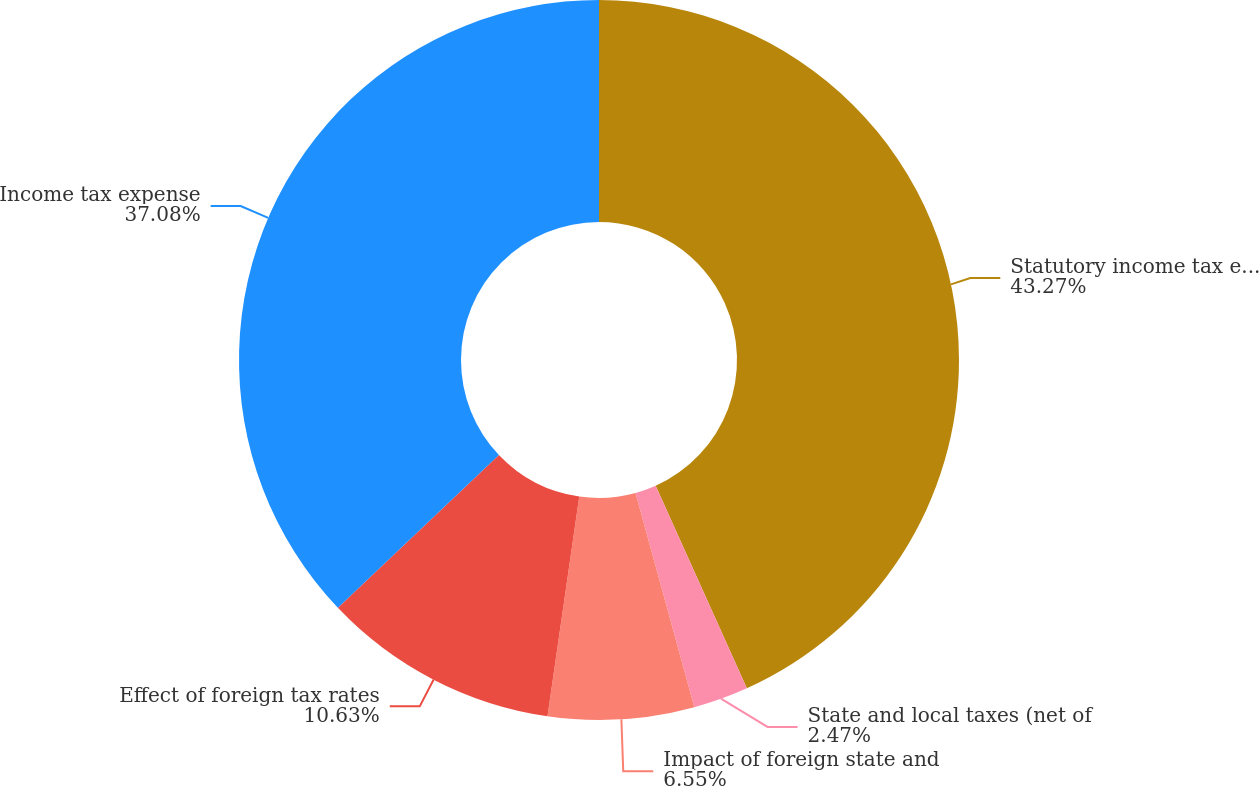Convert chart. <chart><loc_0><loc_0><loc_500><loc_500><pie_chart><fcel>Statutory income tax expense<fcel>State and local taxes (net of<fcel>Impact of foreign state and<fcel>Effect of foreign tax rates<fcel>Income tax expense<nl><fcel>43.26%<fcel>2.47%<fcel>6.55%<fcel>10.63%<fcel>37.08%<nl></chart> 